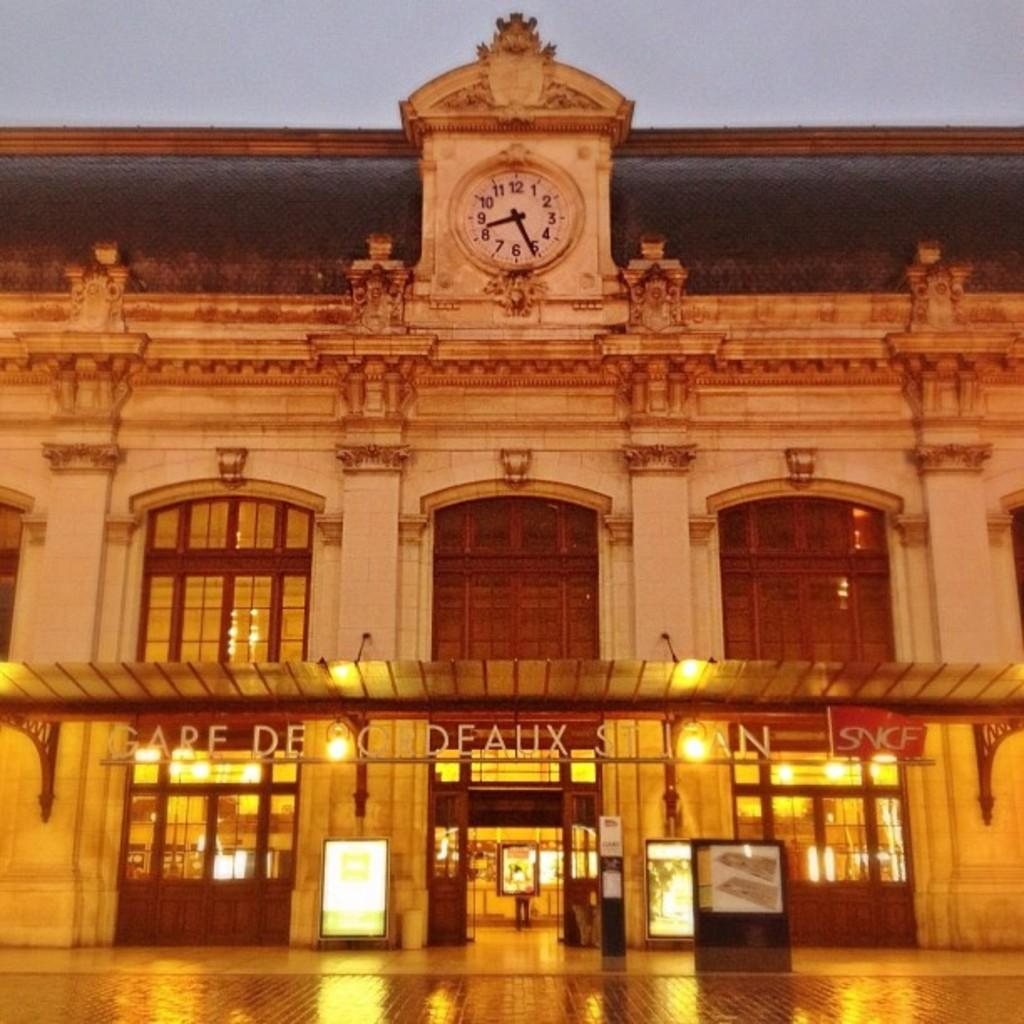What type of structure is visible in the image? There is a building in the image. What features can be observed on the building? The building has many windows and doors. What is located above the building in the image? There is a clock visible above the building. What is visible at the top of the image? The sky is visible at the top of the image. What type of advice can be seen written on the table in the image? There is no table present in the image, and therefore no advice can be seen written on it. 